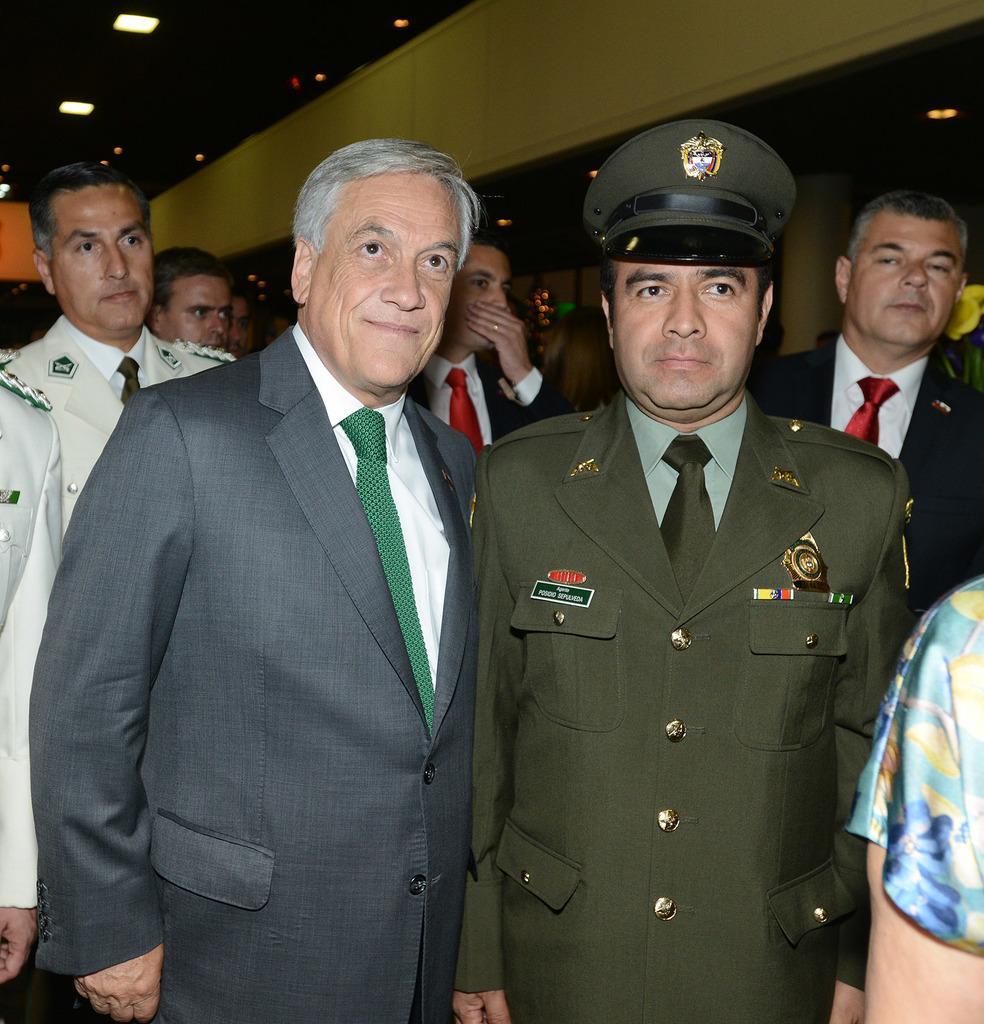Describe this image in one or two sentences. In this image there are group of people standing with blazers and ties, and in the background there are lights, pillar. 